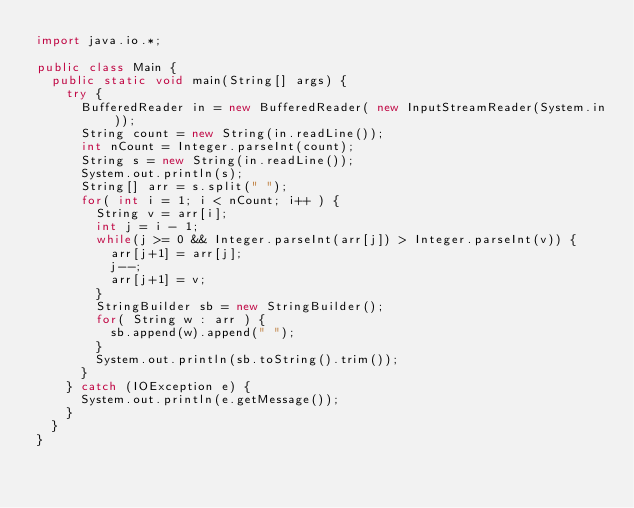<code> <loc_0><loc_0><loc_500><loc_500><_Java_>import java.io.*;

public class Main {
  public static void main(String[] args) {
    try {
      BufferedReader in = new BufferedReader( new InputStreamReader(System.in));
      String count = new String(in.readLine());
      int nCount = Integer.parseInt(count);
      String s = new String(in.readLine());
      System.out.println(s);
      String[] arr = s.split(" ");
      for( int i = 1; i < nCount; i++ ) {
        String v = arr[i];
        int j = i - 1;
        while(j >= 0 && Integer.parseInt(arr[j]) > Integer.parseInt(v)) {
          arr[j+1] = arr[j];
          j--;
          arr[j+1] = v;
        }
        StringBuilder sb = new StringBuilder();
        for( String w : arr ) {
          sb.append(w).append(" ");
        }
        System.out.println(sb.toString().trim());
      }
    } catch (IOException e) {
      System.out.println(e.getMessage());
    }
  }
}</code> 